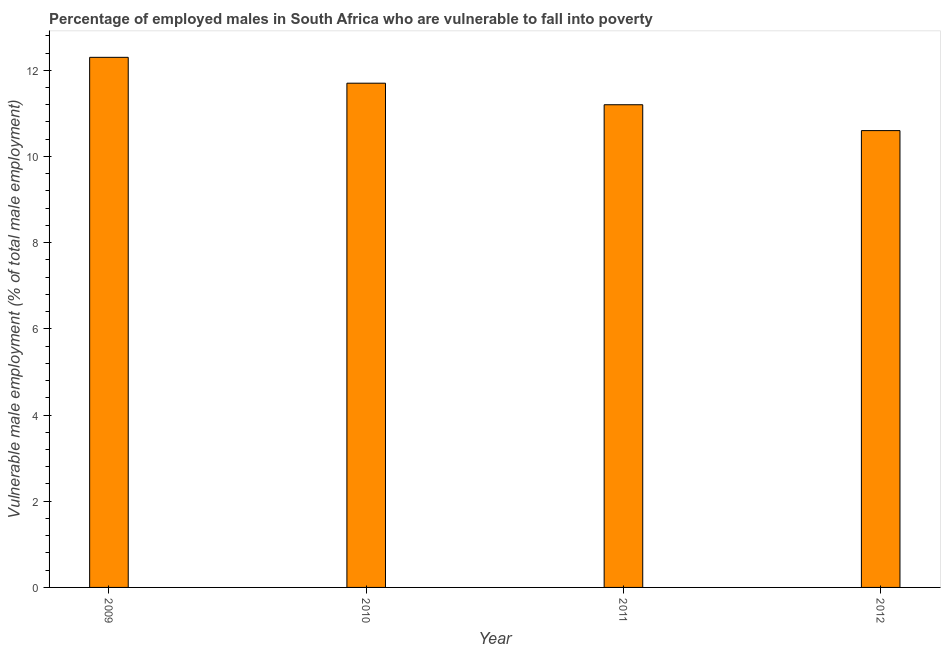Does the graph contain grids?
Keep it short and to the point. No. What is the title of the graph?
Provide a short and direct response. Percentage of employed males in South Africa who are vulnerable to fall into poverty. What is the label or title of the Y-axis?
Ensure brevity in your answer.  Vulnerable male employment (% of total male employment). What is the percentage of employed males who are vulnerable to fall into poverty in 2009?
Ensure brevity in your answer.  12.3. Across all years, what is the maximum percentage of employed males who are vulnerable to fall into poverty?
Offer a very short reply. 12.3. Across all years, what is the minimum percentage of employed males who are vulnerable to fall into poverty?
Your answer should be very brief. 10.6. In which year was the percentage of employed males who are vulnerable to fall into poverty minimum?
Your response must be concise. 2012. What is the sum of the percentage of employed males who are vulnerable to fall into poverty?
Offer a very short reply. 45.8. What is the average percentage of employed males who are vulnerable to fall into poverty per year?
Your answer should be very brief. 11.45. What is the median percentage of employed males who are vulnerable to fall into poverty?
Your answer should be compact. 11.45. In how many years, is the percentage of employed males who are vulnerable to fall into poverty greater than 5.6 %?
Provide a short and direct response. 4. What is the ratio of the percentage of employed males who are vulnerable to fall into poverty in 2010 to that in 2011?
Provide a short and direct response. 1.04. Is the percentage of employed males who are vulnerable to fall into poverty in 2010 less than that in 2012?
Your response must be concise. No. What is the difference between the highest and the second highest percentage of employed males who are vulnerable to fall into poverty?
Make the answer very short. 0.6. Is the sum of the percentage of employed males who are vulnerable to fall into poverty in 2010 and 2011 greater than the maximum percentage of employed males who are vulnerable to fall into poverty across all years?
Make the answer very short. Yes. What is the difference between the highest and the lowest percentage of employed males who are vulnerable to fall into poverty?
Ensure brevity in your answer.  1.7. How many bars are there?
Your answer should be very brief. 4. Are all the bars in the graph horizontal?
Provide a succinct answer. No. How many years are there in the graph?
Your answer should be very brief. 4. What is the Vulnerable male employment (% of total male employment) of 2009?
Make the answer very short. 12.3. What is the Vulnerable male employment (% of total male employment) in 2010?
Ensure brevity in your answer.  11.7. What is the Vulnerable male employment (% of total male employment) of 2011?
Your answer should be compact. 11.2. What is the Vulnerable male employment (% of total male employment) in 2012?
Provide a succinct answer. 10.6. What is the difference between the Vulnerable male employment (% of total male employment) in 2009 and 2011?
Give a very brief answer. 1.1. What is the difference between the Vulnerable male employment (% of total male employment) in 2010 and 2011?
Your answer should be very brief. 0.5. What is the difference between the Vulnerable male employment (% of total male employment) in 2011 and 2012?
Your answer should be compact. 0.6. What is the ratio of the Vulnerable male employment (% of total male employment) in 2009 to that in 2010?
Offer a very short reply. 1.05. What is the ratio of the Vulnerable male employment (% of total male employment) in 2009 to that in 2011?
Your response must be concise. 1.1. What is the ratio of the Vulnerable male employment (% of total male employment) in 2009 to that in 2012?
Offer a very short reply. 1.16. What is the ratio of the Vulnerable male employment (% of total male employment) in 2010 to that in 2011?
Your answer should be very brief. 1.04. What is the ratio of the Vulnerable male employment (% of total male employment) in 2010 to that in 2012?
Your answer should be very brief. 1.1. What is the ratio of the Vulnerable male employment (% of total male employment) in 2011 to that in 2012?
Offer a very short reply. 1.06. 